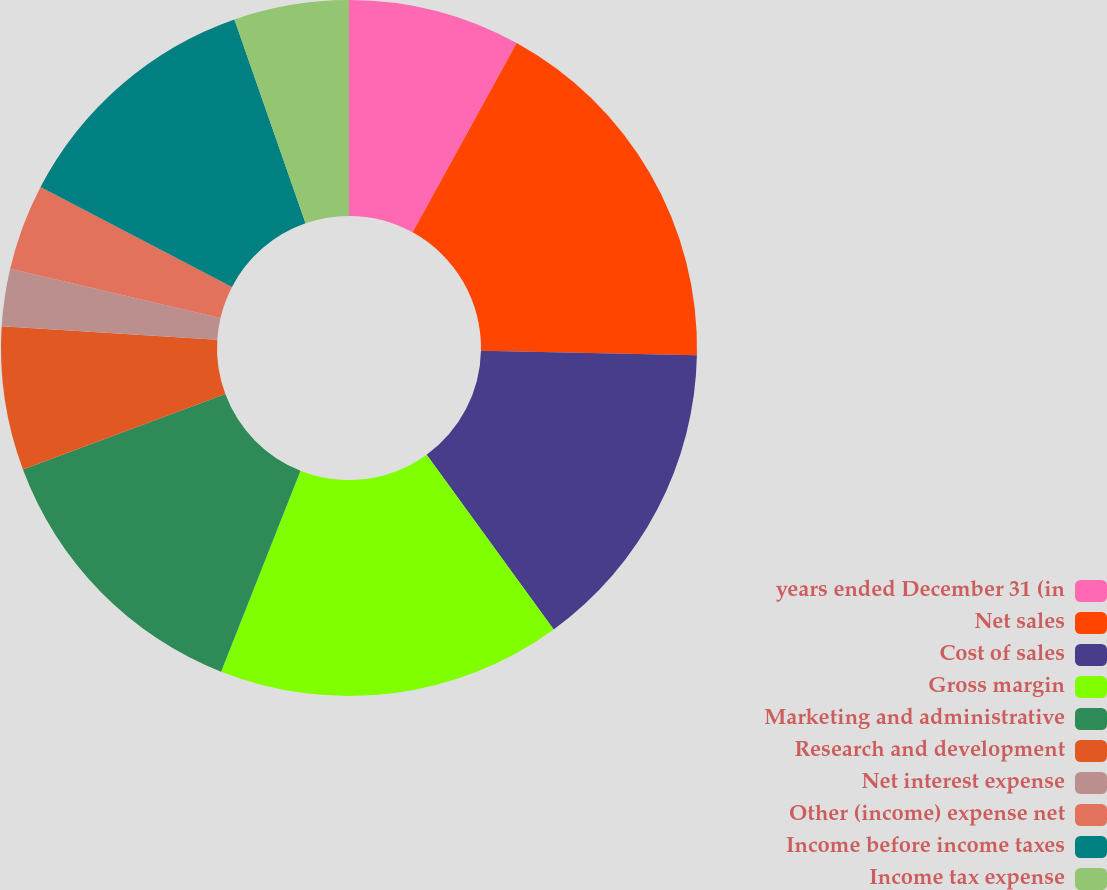<chart> <loc_0><loc_0><loc_500><loc_500><pie_chart><fcel>years ended December 31 (in<fcel>Net sales<fcel>Cost of sales<fcel>Gross margin<fcel>Marketing and administrative<fcel>Research and development<fcel>Net interest expense<fcel>Other (income) expense net<fcel>Income before income taxes<fcel>Income tax expense<nl><fcel>8.0%<fcel>17.33%<fcel>14.66%<fcel>16.0%<fcel>13.33%<fcel>6.67%<fcel>2.67%<fcel>4.0%<fcel>12.0%<fcel>5.34%<nl></chart> 